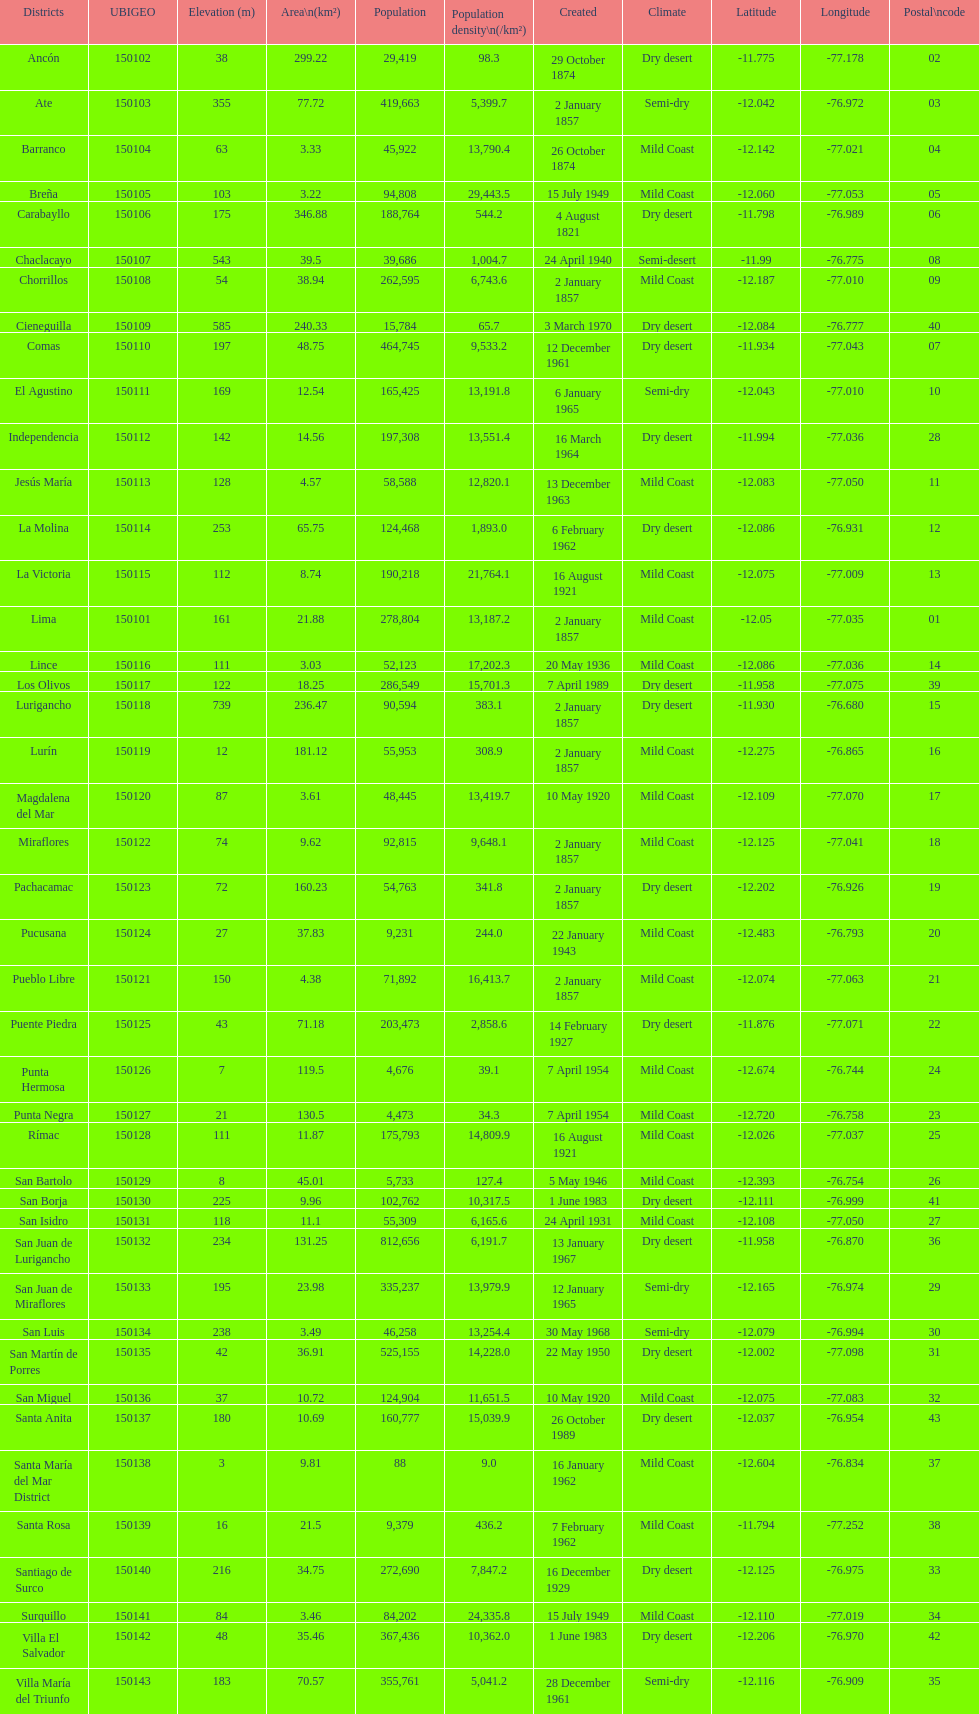What is the total number of districts created in the 1900's? 32. 